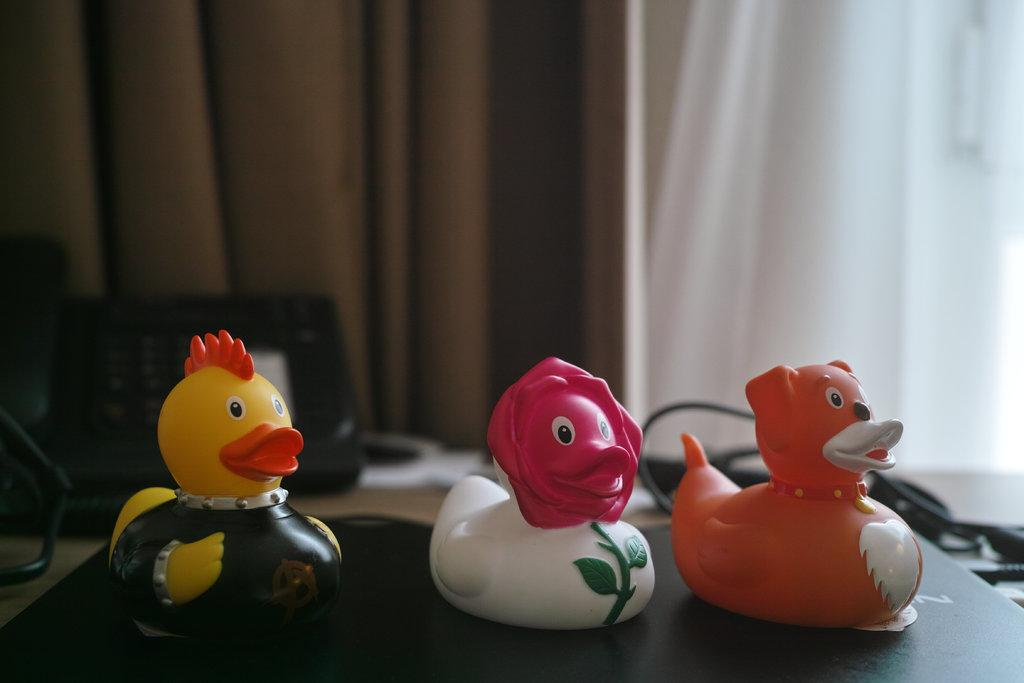What objects are placed on the laptop in the image? There are toy ducks placed on a laptop in the image. What can be seen in the background of the image? There is a telephone and curtains in the background of the image. What else is present in the background of the image? Cables are present in the background of the image. What type of punishment is being administered to the toy ducks in the image? There is no punishment being administered to the toy ducks in the image; they are simply placed on the laptop. 